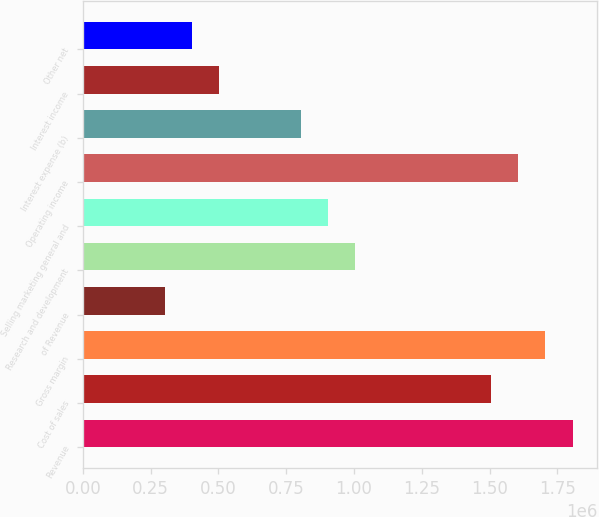Convert chart to OTSL. <chart><loc_0><loc_0><loc_500><loc_500><bar_chart><fcel>Revenue<fcel>Cost of sales<fcel>Gross margin<fcel>of Revenue<fcel>Research and development<fcel>Selling marketing general and<fcel>Operating income<fcel>Interest expense (b)<fcel>Interest income<fcel>Other net<nl><fcel>1.80652e+06<fcel>1.50543e+06<fcel>1.70616e+06<fcel>301087<fcel>1.00362e+06<fcel>903261<fcel>1.6058e+06<fcel>802898<fcel>501812<fcel>401449<nl></chart> 